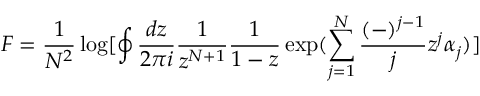Convert formula to latex. <formula><loc_0><loc_0><loc_500><loc_500>F = \frac { 1 } { N ^ { 2 } } \log [ \oint \frac { d z } { 2 \pi i } \frac { 1 } { z ^ { N + 1 } } \frac { 1 } { 1 - z } \exp ( \sum _ { j = 1 } ^ { N } \frac { ( - ) ^ { j - 1 } } { j } z ^ { j } \alpha _ { j } ) ]</formula> 